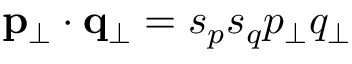<formula> <loc_0><loc_0><loc_500><loc_500>{ p _ { \perp } } \cdot { q _ { \perp } } = s _ { p } s _ { q } p _ { \perp } q _ { \perp }</formula> 